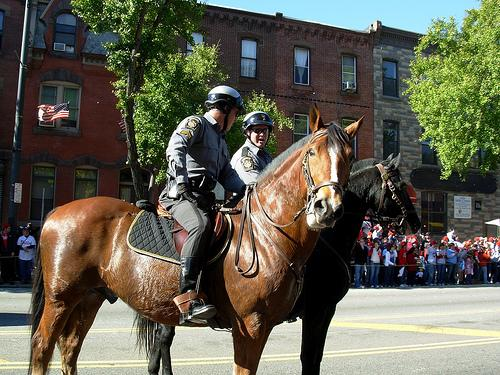What is the main focus of the image and how are they positioned? The main focus is two officers on horseback in the center of the image, with a large crowd in the background and an American flag waving nearby. Identify the uniformed individuals in the image and describe what they are doing. Two officers in uniforms are mounted on horses, talking or interacting with each other while wearing helmets. Briefly describe the scene and the key elements in the image. The image depicts a parade where two officers on horseback converse in the street, with a busy crowd behind them, an American flag in the air, and a row of brick buildings in the background. What type of event might be happening in the image and who are the main participants? It might be a parade or a public event, with the main participants being two officers mounted on horses, a large crowd of onlookers, and the presence of an American flag. 